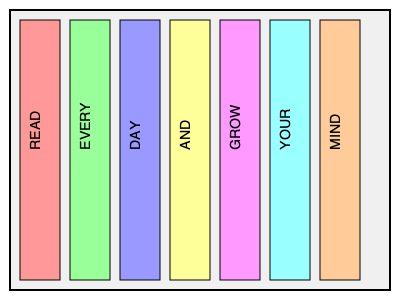Arrange the book spines in the correct order to reveal a hidden message about the benefits of reading. What is the first word of this message? To solve this visual puzzle and reveal the hidden message, follow these steps:

1. Observe that each colored rectangle represents a book spine.
2. Notice that each spine has a word written vertically on it.
3. The current order of the words on the spines is: READ, EVERY, DAY, AND, GROW, YOUR, MIND.
4. To form a coherent message, we need to rearrange the spines.
5. The most logical arrangement that forms a meaningful sentence is:
   READ EVERY DAY AND GROW YOUR MIND
6. This arrangement creates a complete message about the benefits of reading.
7. The question asks for the first word of this message.
8. In the correct arrangement, the first word is "READ".
Answer: READ 